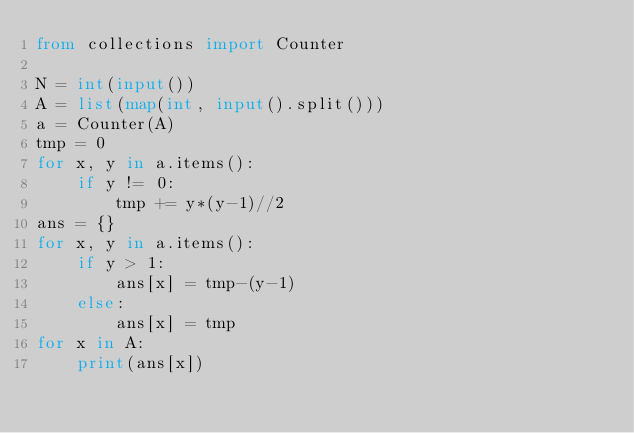Convert code to text. <code><loc_0><loc_0><loc_500><loc_500><_Python_>from collections import Counter

N = int(input())
A = list(map(int, input().split()))
a = Counter(A)
tmp = 0
for x, y in a.items():
    if y != 0:
        tmp += y*(y-1)//2
ans = {}
for x, y in a.items():
    if y > 1:
        ans[x] = tmp-(y-1)
    else:
        ans[x] = tmp
for x in A:
    print(ans[x])
</code> 